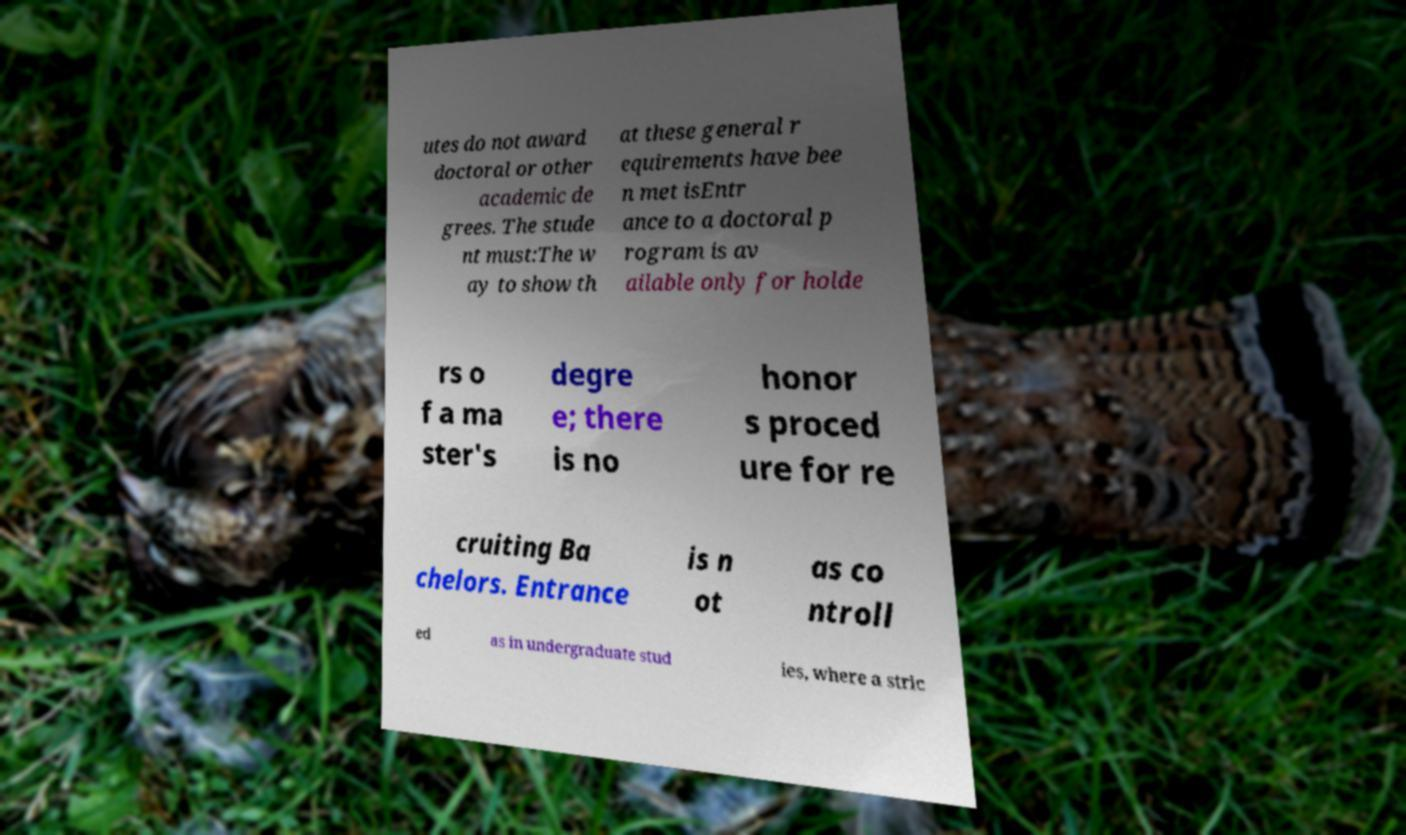What messages or text are displayed in this image? I need them in a readable, typed format. utes do not award doctoral or other academic de grees. The stude nt must:The w ay to show th at these general r equirements have bee n met isEntr ance to a doctoral p rogram is av ailable only for holde rs o f a ma ster's degre e; there is no honor s proced ure for re cruiting Ba chelors. Entrance is n ot as co ntroll ed as in undergraduate stud ies, where a stric 